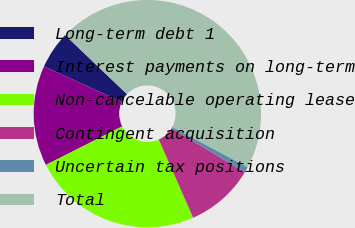Convert chart. <chart><loc_0><loc_0><loc_500><loc_500><pie_chart><fcel>Long-term debt 1<fcel>Interest payments on long-term<fcel>Non-cancelable operating lease<fcel>Contingent acquisition<fcel>Uncertain tax positions<fcel>Total<nl><fcel>5.31%<fcel>14.27%<fcel>24.15%<fcel>9.79%<fcel>0.82%<fcel>45.66%<nl></chart> 